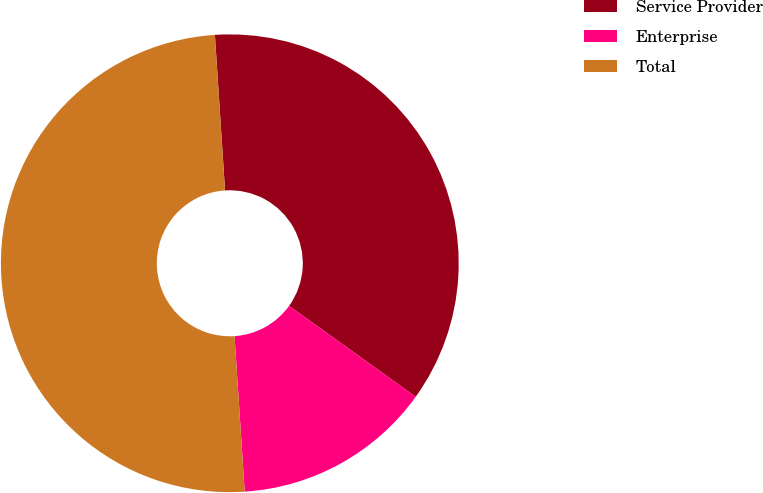Convert chart to OTSL. <chart><loc_0><loc_0><loc_500><loc_500><pie_chart><fcel>Service Provider<fcel>Enterprise<fcel>Total<nl><fcel>35.95%<fcel>14.05%<fcel>50.0%<nl></chart> 